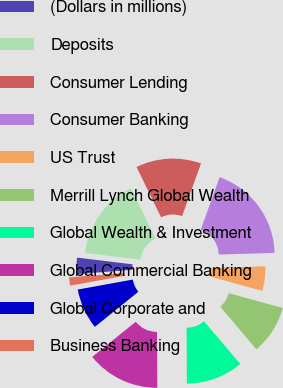Convert chart to OTSL. <chart><loc_0><loc_0><loc_500><loc_500><pie_chart><fcel>(Dollars in millions)<fcel>Deposits<fcel>Consumer Lending<fcel>Consumer Banking<fcel>US Trust<fcel>Merrill Lynch Global Wealth<fcel>Global Wealth & Investment<fcel>Global Commercial Banking<fcel>Global Corporate and<fcel>Business Banking<nl><fcel>3.18%<fcel>15.87%<fcel>12.7%<fcel>19.04%<fcel>4.77%<fcel>9.52%<fcel>11.11%<fcel>14.28%<fcel>7.94%<fcel>1.6%<nl></chart> 